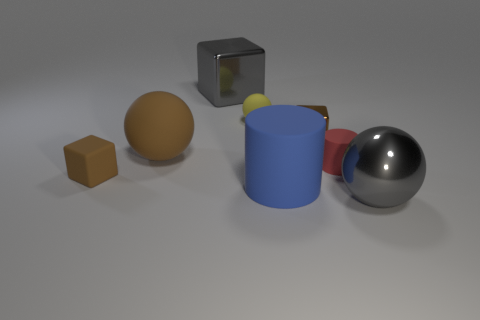How many balls are blue matte objects or small yellow things?
Make the answer very short. 1. There is a tiny brown thing that is in front of the big brown thing; does it have the same shape as the brown metal object?
Your answer should be compact. Yes. What color is the tiny metal object?
Your response must be concise. Brown. What is the color of the other rubber thing that is the same shape as the tiny yellow thing?
Give a very brief answer. Brown. What number of other big things are the same shape as the red object?
Keep it short and to the point. 1. How many things are big brown matte cubes or spheres in front of the big brown sphere?
Give a very brief answer. 1. Do the tiny rubber sphere and the small cube left of the big brown ball have the same color?
Give a very brief answer. No. What is the size of the shiny thing that is on the right side of the small yellow sphere and to the left of the gray ball?
Provide a short and direct response. Small. Are there any gray metal things to the left of the gray metal sphere?
Provide a short and direct response. Yes. There is a large gray block that is behind the large gray metallic ball; is there a large gray ball that is to the left of it?
Provide a succinct answer. No. 